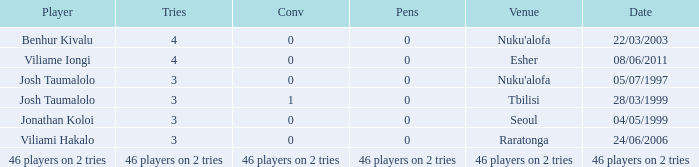Which athlete participated on 04/05/1999 with a conversion of 0? Jonathan Koloi. 